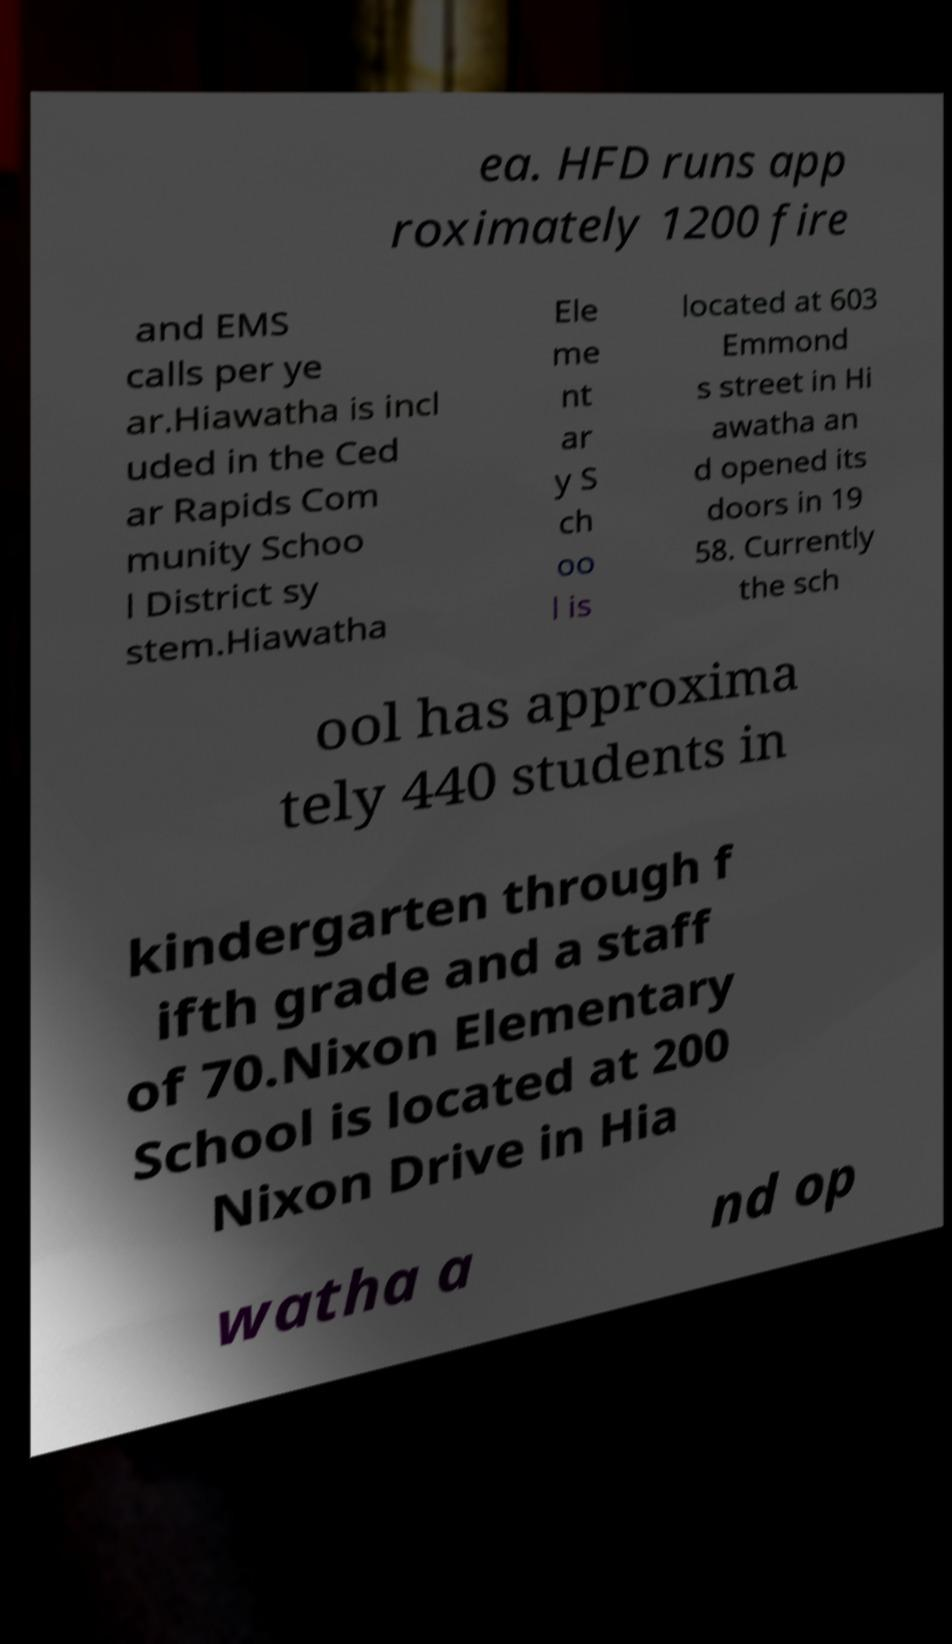Can you read and provide the text displayed in the image?This photo seems to have some interesting text. Can you extract and type it out for me? ea. HFD runs app roximately 1200 fire and EMS calls per ye ar.Hiawatha is incl uded in the Ced ar Rapids Com munity Schoo l District sy stem.Hiawatha Ele me nt ar y S ch oo l is located at 603 Emmond s street in Hi awatha an d opened its doors in 19 58. Currently the sch ool has approxima tely 440 students in kindergarten through f ifth grade and a staff of 70.Nixon Elementary School is located at 200 Nixon Drive in Hia watha a nd op 